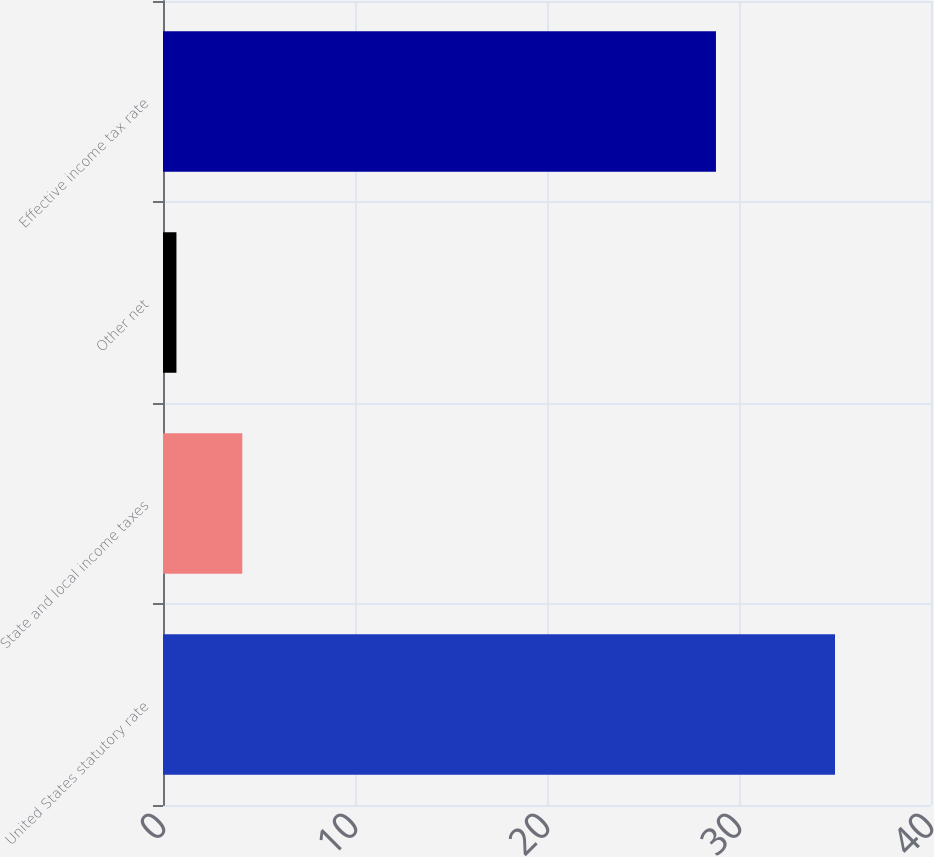Convert chart to OTSL. <chart><loc_0><loc_0><loc_500><loc_500><bar_chart><fcel>United States statutory rate<fcel>State and local income taxes<fcel>Other net<fcel>Effective income tax rate<nl><fcel>35<fcel>4.13<fcel>0.7<fcel>28.8<nl></chart> 